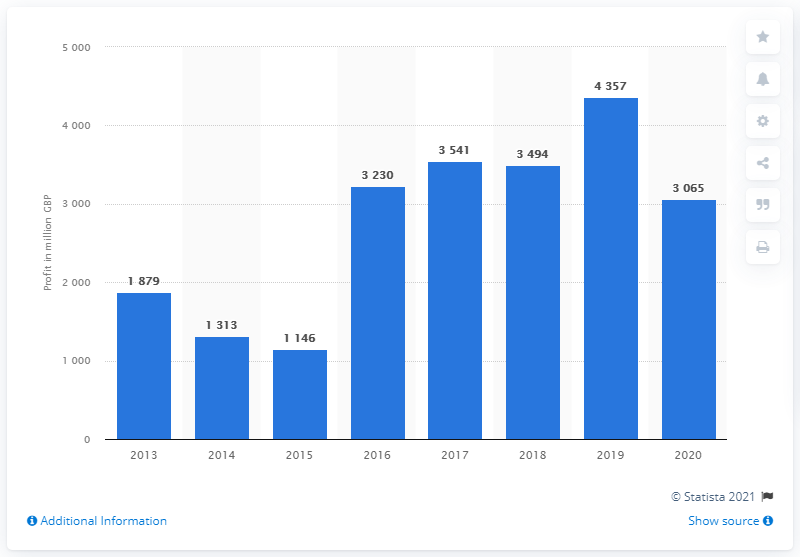Give some essential details in this illustration. In 2013, the global profit before tax of Barclays group was 1879. Barclays group's profit before taxes in 2020 was 3065. 